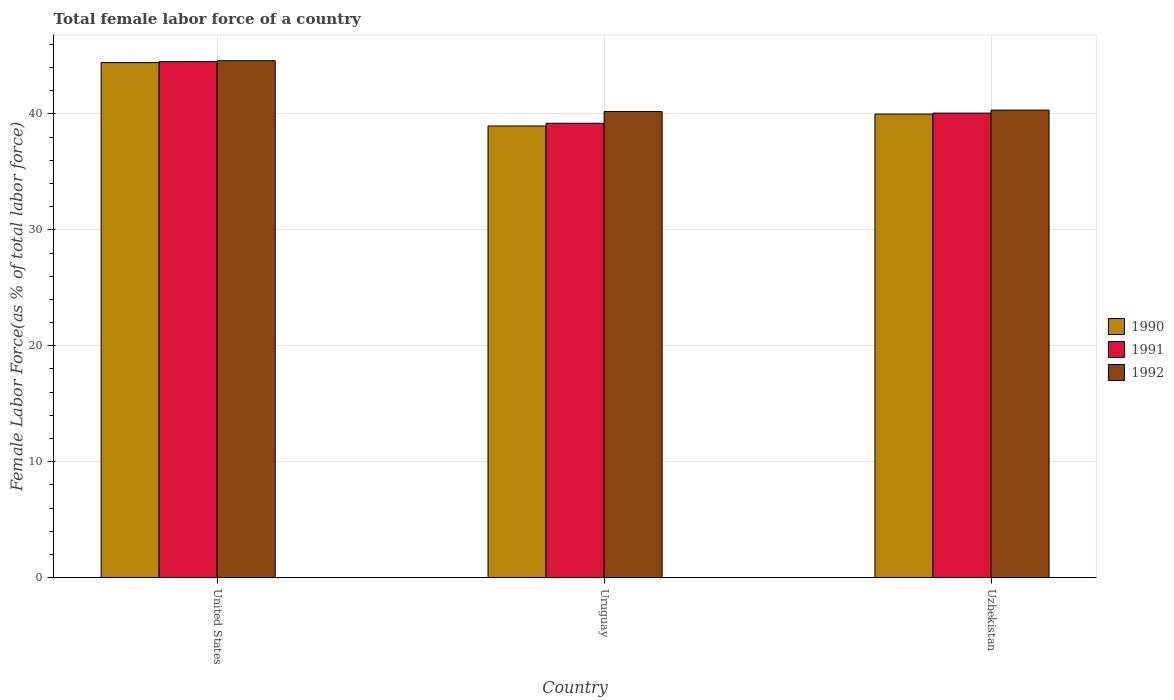How many groups of bars are there?
Your answer should be compact. 3. Are the number of bars per tick equal to the number of legend labels?
Ensure brevity in your answer.  Yes. Are the number of bars on each tick of the X-axis equal?
Provide a succinct answer. Yes. How many bars are there on the 1st tick from the left?
Provide a succinct answer. 3. What is the label of the 2nd group of bars from the left?
Offer a very short reply. Uruguay. In how many cases, is the number of bars for a given country not equal to the number of legend labels?
Your answer should be compact. 0. What is the percentage of female labor force in 1992 in Uruguay?
Your answer should be compact. 40.2. Across all countries, what is the maximum percentage of female labor force in 1991?
Provide a short and direct response. 44.5. Across all countries, what is the minimum percentage of female labor force in 1992?
Provide a short and direct response. 40.2. In which country was the percentage of female labor force in 1992 maximum?
Provide a short and direct response. United States. In which country was the percentage of female labor force in 1991 minimum?
Provide a short and direct response. Uruguay. What is the total percentage of female labor force in 1990 in the graph?
Your response must be concise. 123.36. What is the difference between the percentage of female labor force in 1990 in Uruguay and that in Uzbekistan?
Your response must be concise. -1.03. What is the difference between the percentage of female labor force in 1991 in Uruguay and the percentage of female labor force in 1990 in United States?
Keep it short and to the point. -5.23. What is the average percentage of female labor force in 1991 per country?
Your response must be concise. 41.25. What is the difference between the percentage of female labor force of/in 1991 and percentage of female labor force of/in 1990 in Uruguay?
Make the answer very short. 0.24. What is the ratio of the percentage of female labor force in 1990 in Uruguay to that in Uzbekistan?
Your answer should be very brief. 0.97. Is the percentage of female labor force in 1992 in United States less than that in Uruguay?
Offer a very short reply. No. Is the difference between the percentage of female labor force in 1991 in United States and Uruguay greater than the difference between the percentage of female labor force in 1990 in United States and Uruguay?
Offer a terse response. No. What is the difference between the highest and the second highest percentage of female labor force in 1992?
Make the answer very short. 0.12. What is the difference between the highest and the lowest percentage of female labor force in 1990?
Make the answer very short. 5.47. In how many countries, is the percentage of female labor force in 1990 greater than the average percentage of female labor force in 1990 taken over all countries?
Your answer should be very brief. 1. Is it the case that in every country, the sum of the percentage of female labor force in 1992 and percentage of female labor force in 1991 is greater than the percentage of female labor force in 1990?
Ensure brevity in your answer.  Yes. How many countries are there in the graph?
Provide a short and direct response. 3. What is the difference between two consecutive major ticks on the Y-axis?
Your answer should be compact. 10. Does the graph contain any zero values?
Provide a short and direct response. No. How many legend labels are there?
Your answer should be compact. 3. How are the legend labels stacked?
Offer a very short reply. Vertical. What is the title of the graph?
Ensure brevity in your answer.  Total female labor force of a country. Does "1998" appear as one of the legend labels in the graph?
Keep it short and to the point. No. What is the label or title of the Y-axis?
Offer a very short reply. Female Labor Force(as % of total labor force). What is the Female Labor Force(as % of total labor force) of 1990 in United States?
Make the answer very short. 44.42. What is the Female Labor Force(as % of total labor force) of 1991 in United States?
Keep it short and to the point. 44.5. What is the Female Labor Force(as % of total labor force) of 1992 in United States?
Make the answer very short. 44.58. What is the Female Labor Force(as % of total labor force) of 1990 in Uruguay?
Provide a short and direct response. 38.95. What is the Female Labor Force(as % of total labor force) in 1991 in Uruguay?
Your answer should be compact. 39.19. What is the Female Labor Force(as % of total labor force) in 1992 in Uruguay?
Your answer should be very brief. 40.2. What is the Female Labor Force(as % of total labor force) in 1990 in Uzbekistan?
Provide a short and direct response. 39.98. What is the Female Labor Force(as % of total labor force) in 1991 in Uzbekistan?
Your response must be concise. 40.06. What is the Female Labor Force(as % of total labor force) of 1992 in Uzbekistan?
Your answer should be compact. 40.32. Across all countries, what is the maximum Female Labor Force(as % of total labor force) of 1990?
Offer a very short reply. 44.42. Across all countries, what is the maximum Female Labor Force(as % of total labor force) of 1991?
Ensure brevity in your answer.  44.5. Across all countries, what is the maximum Female Labor Force(as % of total labor force) in 1992?
Your response must be concise. 44.58. Across all countries, what is the minimum Female Labor Force(as % of total labor force) of 1990?
Provide a succinct answer. 38.95. Across all countries, what is the minimum Female Labor Force(as % of total labor force) of 1991?
Keep it short and to the point. 39.19. Across all countries, what is the minimum Female Labor Force(as % of total labor force) in 1992?
Keep it short and to the point. 40.2. What is the total Female Labor Force(as % of total labor force) in 1990 in the graph?
Ensure brevity in your answer.  123.36. What is the total Female Labor Force(as % of total labor force) of 1991 in the graph?
Your answer should be compact. 123.76. What is the total Female Labor Force(as % of total labor force) of 1992 in the graph?
Make the answer very short. 125.1. What is the difference between the Female Labor Force(as % of total labor force) of 1990 in United States and that in Uruguay?
Offer a terse response. 5.47. What is the difference between the Female Labor Force(as % of total labor force) of 1991 in United States and that in Uruguay?
Ensure brevity in your answer.  5.31. What is the difference between the Female Labor Force(as % of total labor force) in 1992 in United States and that in Uruguay?
Your answer should be very brief. 4.38. What is the difference between the Female Labor Force(as % of total labor force) in 1990 in United States and that in Uzbekistan?
Keep it short and to the point. 4.44. What is the difference between the Female Labor Force(as % of total labor force) in 1991 in United States and that in Uzbekistan?
Offer a terse response. 4.44. What is the difference between the Female Labor Force(as % of total labor force) of 1992 in United States and that in Uzbekistan?
Offer a terse response. 4.26. What is the difference between the Female Labor Force(as % of total labor force) of 1990 in Uruguay and that in Uzbekistan?
Your answer should be compact. -1.03. What is the difference between the Female Labor Force(as % of total labor force) in 1991 in Uruguay and that in Uzbekistan?
Your response must be concise. -0.87. What is the difference between the Female Labor Force(as % of total labor force) in 1992 in Uruguay and that in Uzbekistan?
Offer a terse response. -0.12. What is the difference between the Female Labor Force(as % of total labor force) of 1990 in United States and the Female Labor Force(as % of total labor force) of 1991 in Uruguay?
Give a very brief answer. 5.23. What is the difference between the Female Labor Force(as % of total labor force) in 1990 in United States and the Female Labor Force(as % of total labor force) in 1992 in Uruguay?
Offer a terse response. 4.22. What is the difference between the Female Labor Force(as % of total labor force) in 1991 in United States and the Female Labor Force(as % of total labor force) in 1992 in Uruguay?
Your answer should be compact. 4.3. What is the difference between the Female Labor Force(as % of total labor force) in 1990 in United States and the Female Labor Force(as % of total labor force) in 1991 in Uzbekistan?
Give a very brief answer. 4.36. What is the difference between the Female Labor Force(as % of total labor force) of 1990 in United States and the Female Labor Force(as % of total labor force) of 1992 in Uzbekistan?
Your response must be concise. 4.1. What is the difference between the Female Labor Force(as % of total labor force) in 1991 in United States and the Female Labor Force(as % of total labor force) in 1992 in Uzbekistan?
Offer a very short reply. 4.18. What is the difference between the Female Labor Force(as % of total labor force) of 1990 in Uruguay and the Female Labor Force(as % of total labor force) of 1991 in Uzbekistan?
Make the answer very short. -1.11. What is the difference between the Female Labor Force(as % of total labor force) in 1990 in Uruguay and the Female Labor Force(as % of total labor force) in 1992 in Uzbekistan?
Give a very brief answer. -1.37. What is the difference between the Female Labor Force(as % of total labor force) of 1991 in Uruguay and the Female Labor Force(as % of total labor force) of 1992 in Uzbekistan?
Keep it short and to the point. -1.13. What is the average Female Labor Force(as % of total labor force) of 1990 per country?
Offer a terse response. 41.12. What is the average Female Labor Force(as % of total labor force) of 1991 per country?
Provide a short and direct response. 41.25. What is the average Female Labor Force(as % of total labor force) in 1992 per country?
Keep it short and to the point. 41.7. What is the difference between the Female Labor Force(as % of total labor force) in 1990 and Female Labor Force(as % of total labor force) in 1991 in United States?
Offer a terse response. -0.08. What is the difference between the Female Labor Force(as % of total labor force) of 1990 and Female Labor Force(as % of total labor force) of 1992 in United States?
Give a very brief answer. -0.16. What is the difference between the Female Labor Force(as % of total labor force) in 1991 and Female Labor Force(as % of total labor force) in 1992 in United States?
Provide a succinct answer. -0.08. What is the difference between the Female Labor Force(as % of total labor force) in 1990 and Female Labor Force(as % of total labor force) in 1991 in Uruguay?
Give a very brief answer. -0.24. What is the difference between the Female Labor Force(as % of total labor force) of 1990 and Female Labor Force(as % of total labor force) of 1992 in Uruguay?
Keep it short and to the point. -1.24. What is the difference between the Female Labor Force(as % of total labor force) of 1991 and Female Labor Force(as % of total labor force) of 1992 in Uruguay?
Your response must be concise. -1.01. What is the difference between the Female Labor Force(as % of total labor force) in 1990 and Female Labor Force(as % of total labor force) in 1991 in Uzbekistan?
Your answer should be very brief. -0.08. What is the difference between the Female Labor Force(as % of total labor force) of 1990 and Female Labor Force(as % of total labor force) of 1992 in Uzbekistan?
Keep it short and to the point. -0.34. What is the difference between the Female Labor Force(as % of total labor force) in 1991 and Female Labor Force(as % of total labor force) in 1992 in Uzbekistan?
Offer a very short reply. -0.26. What is the ratio of the Female Labor Force(as % of total labor force) of 1990 in United States to that in Uruguay?
Make the answer very short. 1.14. What is the ratio of the Female Labor Force(as % of total labor force) of 1991 in United States to that in Uruguay?
Give a very brief answer. 1.14. What is the ratio of the Female Labor Force(as % of total labor force) of 1992 in United States to that in Uruguay?
Ensure brevity in your answer.  1.11. What is the ratio of the Female Labor Force(as % of total labor force) in 1990 in United States to that in Uzbekistan?
Provide a short and direct response. 1.11. What is the ratio of the Female Labor Force(as % of total labor force) in 1991 in United States to that in Uzbekistan?
Keep it short and to the point. 1.11. What is the ratio of the Female Labor Force(as % of total labor force) of 1992 in United States to that in Uzbekistan?
Offer a terse response. 1.11. What is the ratio of the Female Labor Force(as % of total labor force) of 1990 in Uruguay to that in Uzbekistan?
Give a very brief answer. 0.97. What is the ratio of the Female Labor Force(as % of total labor force) of 1991 in Uruguay to that in Uzbekistan?
Provide a succinct answer. 0.98. What is the ratio of the Female Labor Force(as % of total labor force) of 1992 in Uruguay to that in Uzbekistan?
Your answer should be compact. 1. What is the difference between the highest and the second highest Female Labor Force(as % of total labor force) in 1990?
Your answer should be compact. 4.44. What is the difference between the highest and the second highest Female Labor Force(as % of total labor force) of 1991?
Make the answer very short. 4.44. What is the difference between the highest and the second highest Female Labor Force(as % of total labor force) of 1992?
Keep it short and to the point. 4.26. What is the difference between the highest and the lowest Female Labor Force(as % of total labor force) of 1990?
Offer a very short reply. 5.47. What is the difference between the highest and the lowest Female Labor Force(as % of total labor force) of 1991?
Your response must be concise. 5.31. What is the difference between the highest and the lowest Female Labor Force(as % of total labor force) in 1992?
Make the answer very short. 4.38. 